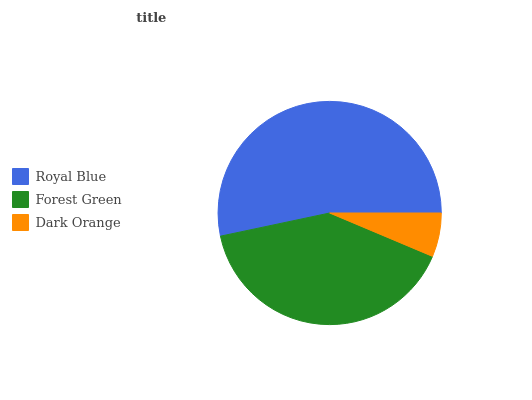Is Dark Orange the minimum?
Answer yes or no. Yes. Is Royal Blue the maximum?
Answer yes or no. Yes. Is Forest Green the minimum?
Answer yes or no. No. Is Forest Green the maximum?
Answer yes or no. No. Is Royal Blue greater than Forest Green?
Answer yes or no. Yes. Is Forest Green less than Royal Blue?
Answer yes or no. Yes. Is Forest Green greater than Royal Blue?
Answer yes or no. No. Is Royal Blue less than Forest Green?
Answer yes or no. No. Is Forest Green the high median?
Answer yes or no. Yes. Is Forest Green the low median?
Answer yes or no. Yes. Is Dark Orange the high median?
Answer yes or no. No. Is Dark Orange the low median?
Answer yes or no. No. 